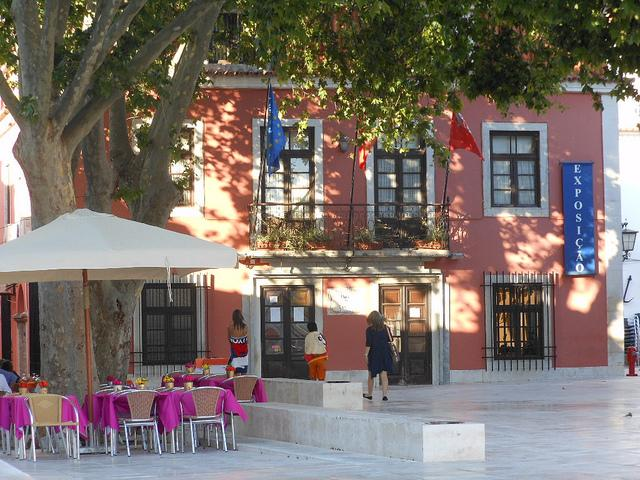What event is being held here?

Choices:
A) wedding
B) tractor pull
C) expo
D) jail break expo 